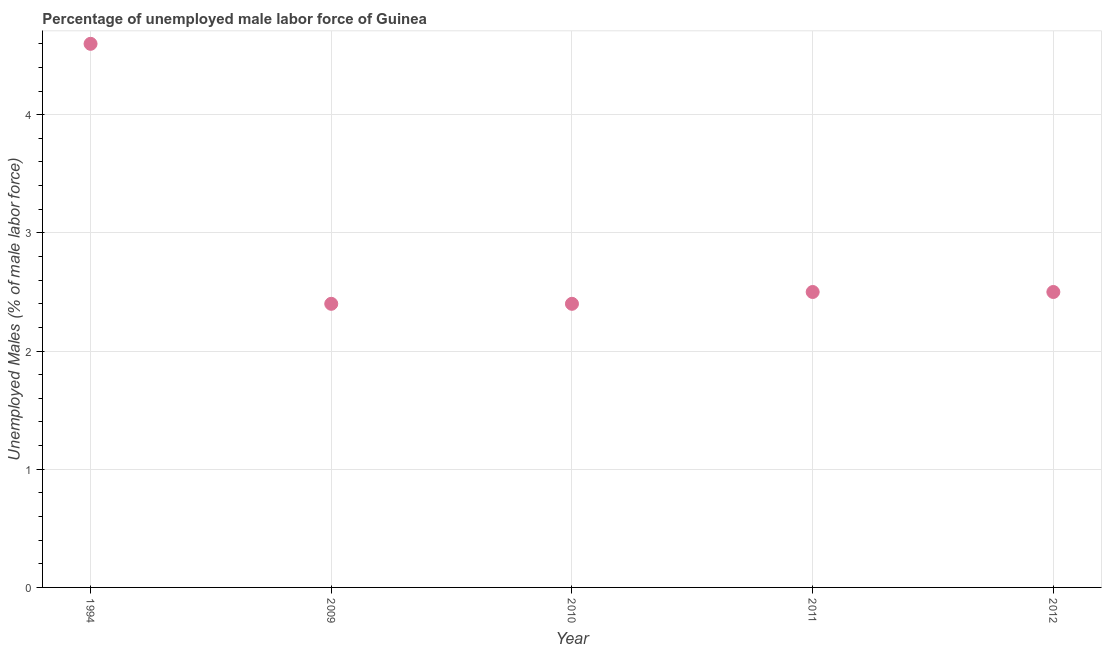What is the total unemployed male labour force in 1994?
Keep it short and to the point. 4.6. Across all years, what is the maximum total unemployed male labour force?
Ensure brevity in your answer.  4.6. Across all years, what is the minimum total unemployed male labour force?
Make the answer very short. 2.4. In which year was the total unemployed male labour force maximum?
Offer a very short reply. 1994. In which year was the total unemployed male labour force minimum?
Provide a succinct answer. 2009. What is the sum of the total unemployed male labour force?
Your response must be concise. 14.4. What is the difference between the total unemployed male labour force in 2010 and 2011?
Your answer should be compact. -0.1. What is the average total unemployed male labour force per year?
Keep it short and to the point. 2.88. What is the ratio of the total unemployed male labour force in 1994 to that in 2012?
Provide a succinct answer. 1.84. Is the total unemployed male labour force in 2009 less than that in 2011?
Make the answer very short. Yes. Is the difference between the total unemployed male labour force in 2010 and 2012 greater than the difference between any two years?
Offer a very short reply. No. What is the difference between the highest and the second highest total unemployed male labour force?
Offer a very short reply. 2.1. What is the difference between the highest and the lowest total unemployed male labour force?
Offer a very short reply. 2.2. Does the total unemployed male labour force monotonically increase over the years?
Your response must be concise. No. How many dotlines are there?
Provide a succinct answer. 1. What is the difference between two consecutive major ticks on the Y-axis?
Make the answer very short. 1. Are the values on the major ticks of Y-axis written in scientific E-notation?
Your answer should be compact. No. Does the graph contain grids?
Keep it short and to the point. Yes. What is the title of the graph?
Your answer should be compact. Percentage of unemployed male labor force of Guinea. What is the label or title of the X-axis?
Ensure brevity in your answer.  Year. What is the label or title of the Y-axis?
Keep it short and to the point. Unemployed Males (% of male labor force). What is the Unemployed Males (% of male labor force) in 1994?
Your answer should be compact. 4.6. What is the Unemployed Males (% of male labor force) in 2009?
Keep it short and to the point. 2.4. What is the Unemployed Males (% of male labor force) in 2010?
Give a very brief answer. 2.4. What is the Unemployed Males (% of male labor force) in 2011?
Provide a succinct answer. 2.5. What is the Unemployed Males (% of male labor force) in 2012?
Provide a short and direct response. 2.5. What is the difference between the Unemployed Males (% of male labor force) in 1994 and 2009?
Keep it short and to the point. 2.2. What is the difference between the Unemployed Males (% of male labor force) in 2009 and 2010?
Keep it short and to the point. 0. What is the difference between the Unemployed Males (% of male labor force) in 2009 and 2011?
Your answer should be compact. -0.1. What is the difference between the Unemployed Males (% of male labor force) in 2010 and 2011?
Make the answer very short. -0.1. What is the difference between the Unemployed Males (% of male labor force) in 2010 and 2012?
Your answer should be very brief. -0.1. What is the difference between the Unemployed Males (% of male labor force) in 2011 and 2012?
Ensure brevity in your answer.  0. What is the ratio of the Unemployed Males (% of male labor force) in 1994 to that in 2009?
Your answer should be compact. 1.92. What is the ratio of the Unemployed Males (% of male labor force) in 1994 to that in 2010?
Offer a very short reply. 1.92. What is the ratio of the Unemployed Males (% of male labor force) in 1994 to that in 2011?
Ensure brevity in your answer.  1.84. What is the ratio of the Unemployed Males (% of male labor force) in 1994 to that in 2012?
Make the answer very short. 1.84. What is the ratio of the Unemployed Males (% of male labor force) in 2009 to that in 2010?
Provide a succinct answer. 1. What is the ratio of the Unemployed Males (% of male labor force) in 2009 to that in 2012?
Your answer should be compact. 0.96. What is the ratio of the Unemployed Males (% of male labor force) in 2010 to that in 2011?
Make the answer very short. 0.96. What is the ratio of the Unemployed Males (% of male labor force) in 2010 to that in 2012?
Your answer should be compact. 0.96. 